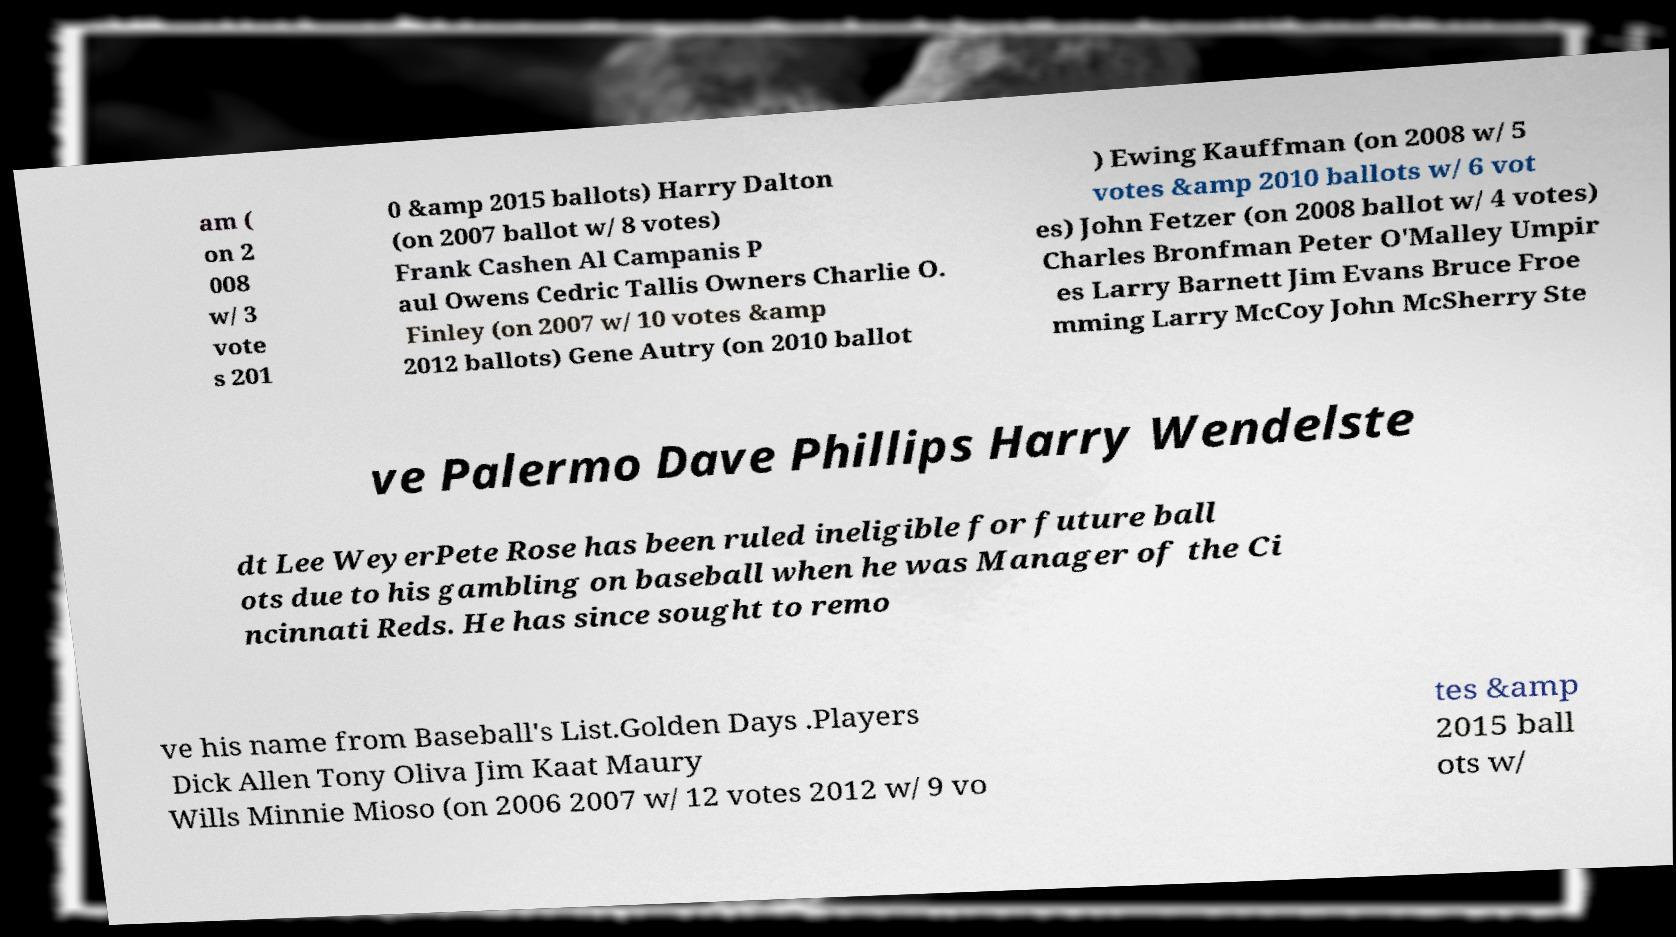I need the written content from this picture converted into text. Can you do that? am ( on 2 008 w/ 3 vote s 201 0 &amp 2015 ballots) Harry Dalton (on 2007 ballot w/ 8 votes) Frank Cashen Al Campanis P aul Owens Cedric Tallis Owners Charlie O. Finley (on 2007 w/ 10 votes &amp 2012 ballots) Gene Autry (on 2010 ballot ) Ewing Kauffman (on 2008 w/ 5 votes &amp 2010 ballots w/ 6 vot es) John Fetzer (on 2008 ballot w/ 4 votes) Charles Bronfman Peter O'Malley Umpir es Larry Barnett Jim Evans Bruce Froe mming Larry McCoy John McSherry Ste ve Palermo Dave Phillips Harry Wendelste dt Lee WeyerPete Rose has been ruled ineligible for future ball ots due to his gambling on baseball when he was Manager of the Ci ncinnati Reds. He has since sought to remo ve his name from Baseball's List.Golden Days .Players Dick Allen Tony Oliva Jim Kaat Maury Wills Minnie Mioso (on 2006 2007 w/ 12 votes 2012 w/ 9 vo tes &amp 2015 ball ots w/ 